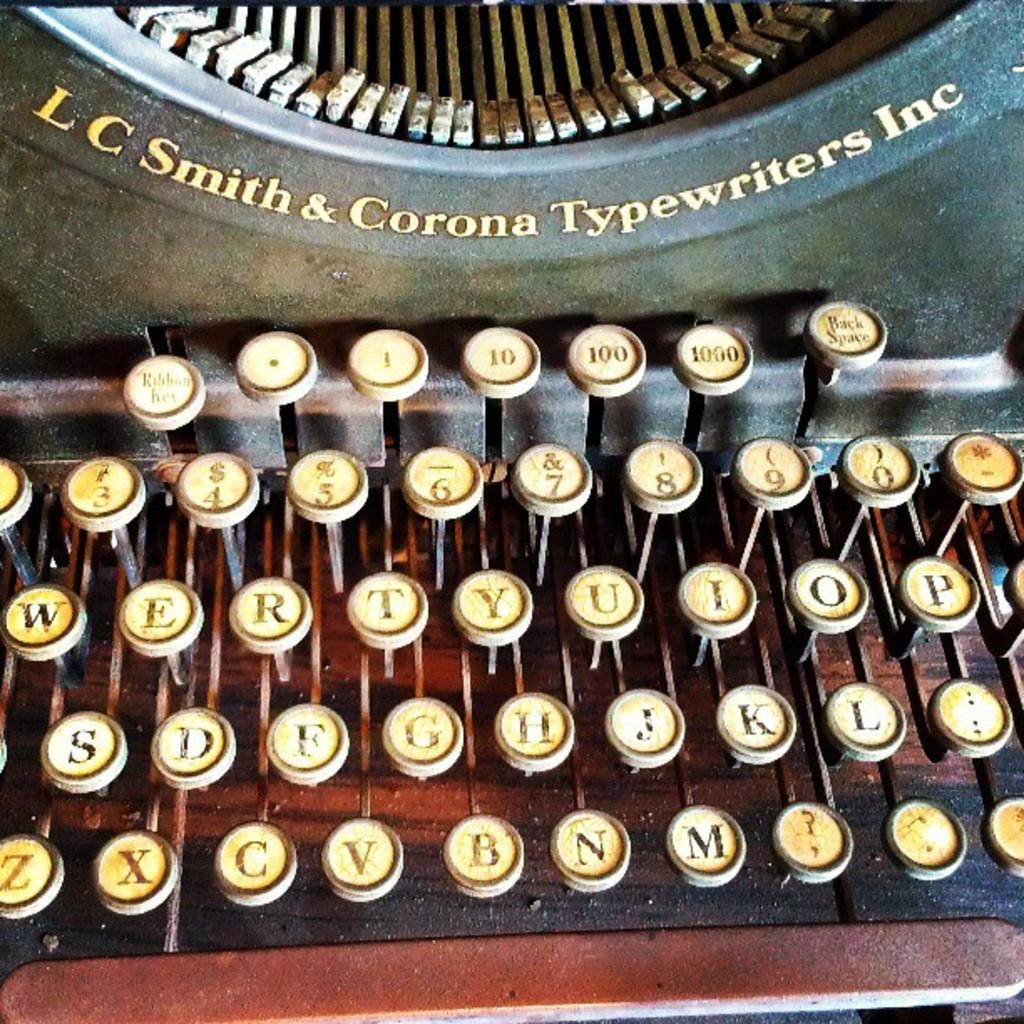Who is the maker of this typewriter?
Give a very brief answer. Lc smith & corona typewriters inc. What are the letters in the bottom row?
Keep it short and to the point. Zxcvbnm. 